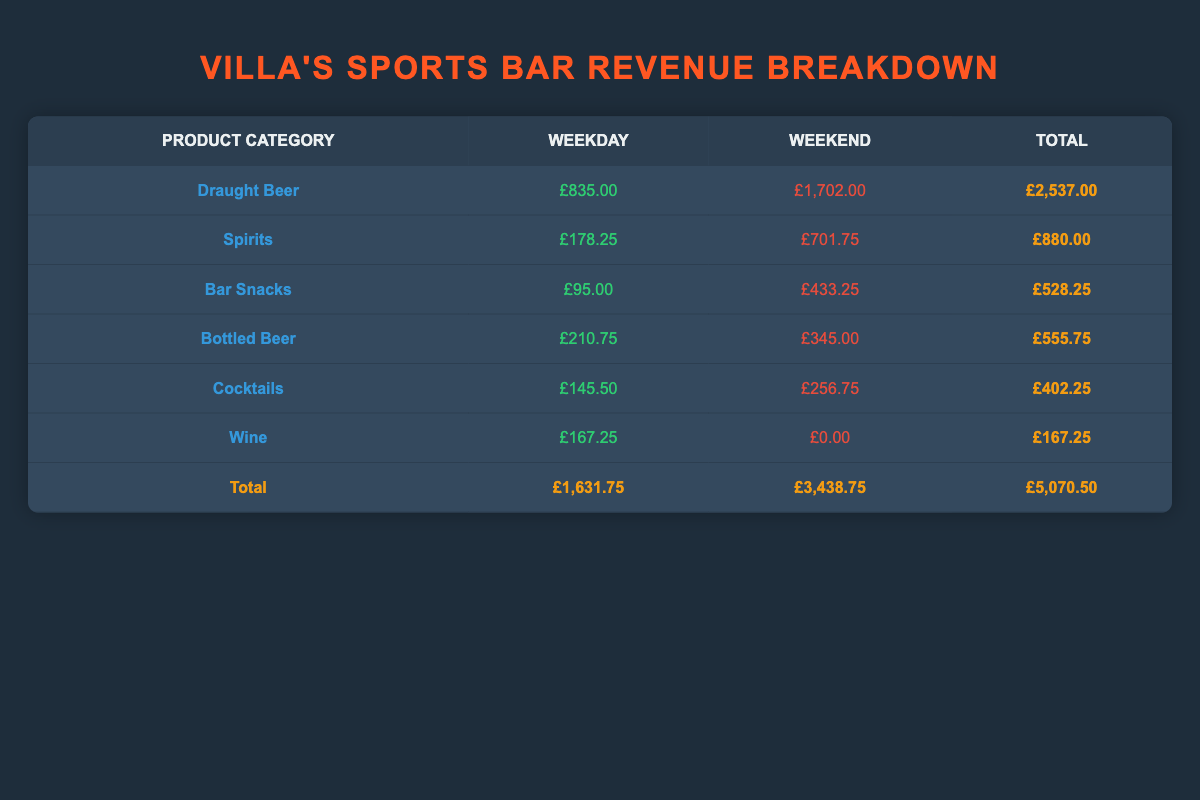What is the total revenue generated from Draught Beer for the weekend? The table shows that the total revenue for Draught Beer during the weekend is £1,702.00. This is taken from the "Weekend" column corresponding to the "Draught Beer" row.
Answer: £1,702.00 How much more revenue did the bar earn from Spirits on weekends compared to weekdays? According to the table, revenue from Spirits on weekdays is £178.25 and on weekends is £701.75. The difference is calculated as 701.75 - 178.25 = £523.50.
Answer: £523.50 Did the revenue from Bar Snacks increase from weekdays to weekends? The revenue for Bar Snacks is £95.00 on weekdays and £433.25 on weekends. This indicates an increase since £433.25 > £95.00, confirming the statement is true.
Answer: Yes What is the total revenue from all product categories on weekdays? Summing the "Weekday" column values gives £1,631.75 (Draught Beer £835.00 + Spirits £178.25 + Bar Snacks £95.00 + Bottled Beer £210.75 + Cocktails £145.50 + Wine £167.25).
Answer: £1,631.75 Which product category generated the highest total revenue for both weekdays and weekends combined? By examining the Total column, Draught Beer has the highest total revenue at £2,537.00, followed by Spirits at £880.00. Draught Beer is therefore the category with the highest revenue.
Answer: Draught Beer What is the average revenue from Cocktails across both weekdays and weekends? Cocktails earned £145.50 on weekdays and £256.75 on weekends. The average is calculated as (145.50 + 256.75) / 2 = £201.13.
Answer: £201.13 How many product categories generated more revenue on weekends than on weekdays? Assessing the table, Draught Beer, Spirits, Bar Snacks, and Cocktails all have higher weekend revenue than weekday revenue. There are four categories that fit this criteria.
Answer: 4 Is the total revenue greater on weekends compared to weekdays? The total revenue for weekends is £3,438.75, while for weekdays it is £1,631.75. Since £3,438.75 > £1,631.75, this statement is true.
Answer: Yes 